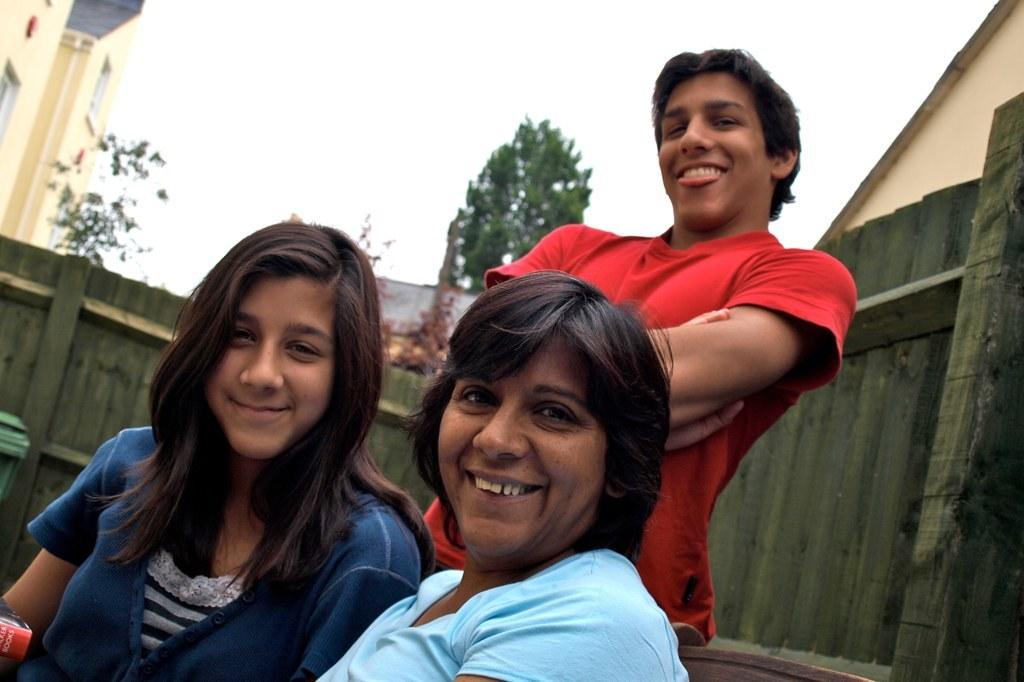Who is present in the image? There are people in the image. What is the facial expression of the people in the image? The people are smiling. What are the people wearing in the image? The people are wearing different color dresses. What type of natural elements can be seen in the image? There are trees in the image. What type of man-made structures can be seen in the image? There are buildings in the image. What part of the natural environment is visible in the image? The sky is visible in the image. What type of fencing is present in the image? There is wooden fencing in the image. What type of pickle is being used as a hat in the image? There is no pickle present in the image, let alone one being used as a hat. 